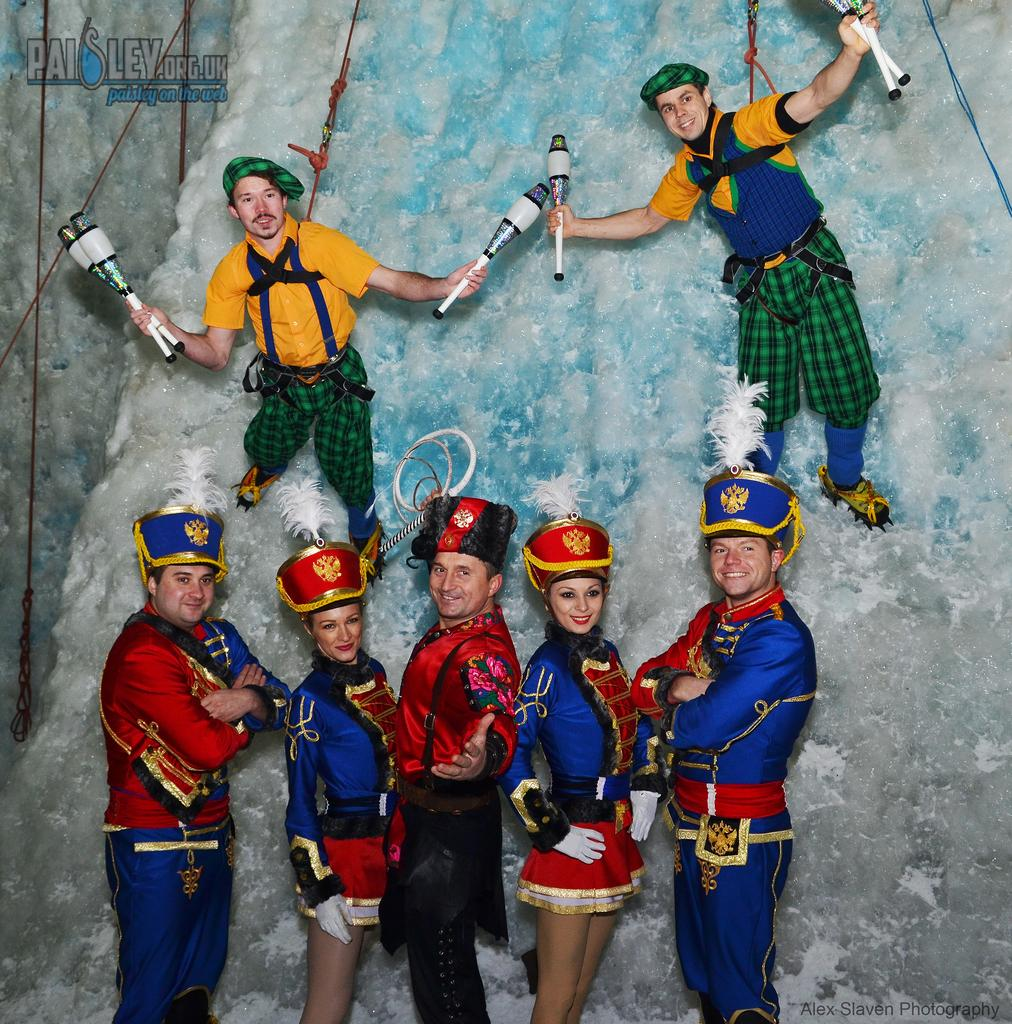How many people are present in the image? There are five people in the image. What are the people doing in the image? The people are standing. Are any of the people holding anything? Yes, two of the people are holding objects. Can you describe any additional features of the image? There is a watermark at the top of the image. What type of scent can be detected from the people in the image? There is no information about the scent of the people in the image, as it is a visual medium. --- 